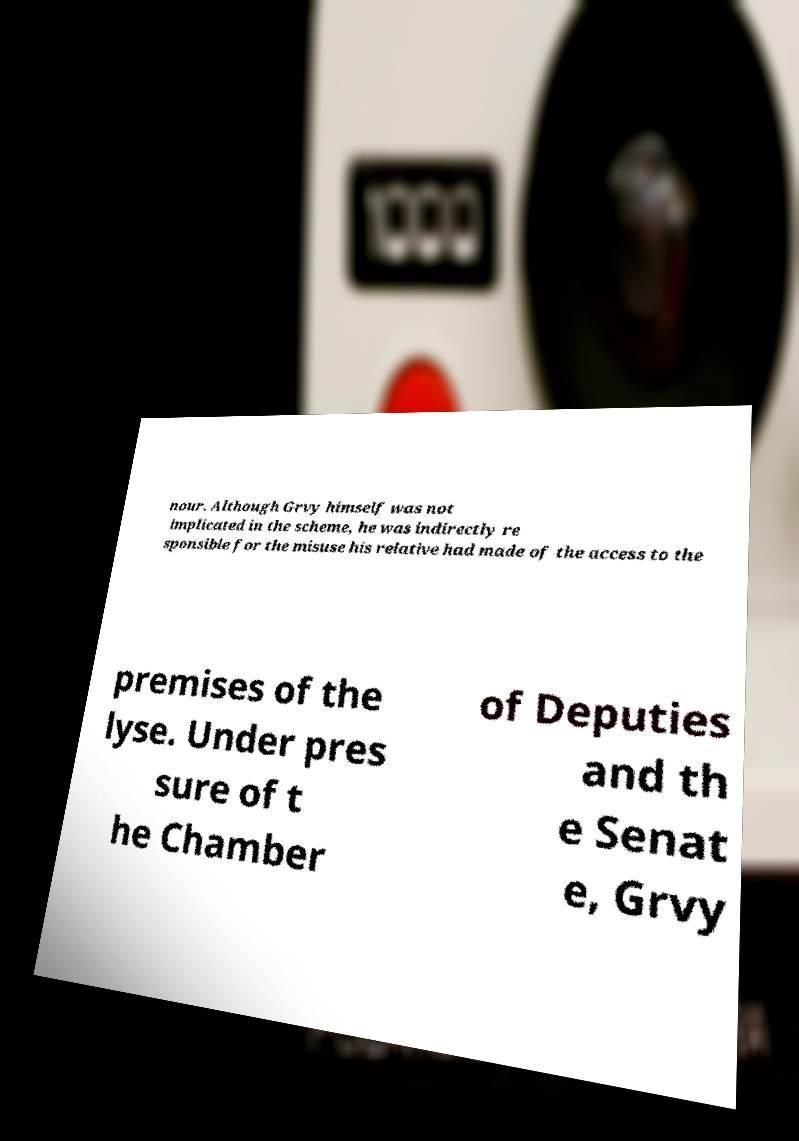I need the written content from this picture converted into text. Can you do that? nour. Although Grvy himself was not implicated in the scheme, he was indirectly re sponsible for the misuse his relative had made of the access to the premises of the lyse. Under pres sure of t he Chamber of Deputies and th e Senat e, Grvy 